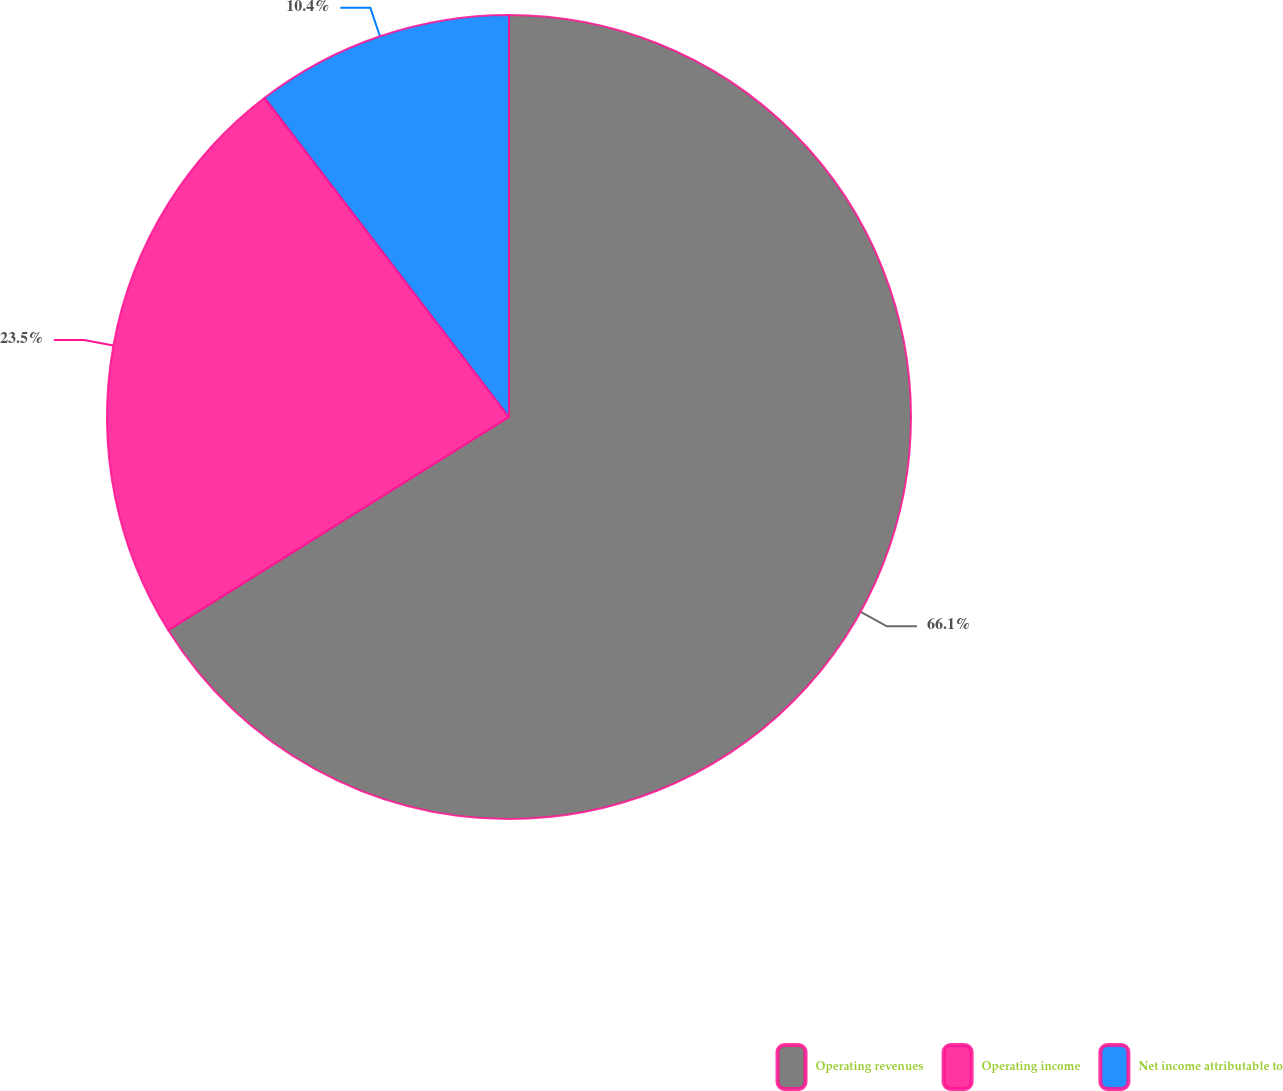<chart> <loc_0><loc_0><loc_500><loc_500><pie_chart><fcel>Operating revenues<fcel>Operating income<fcel>Net income attributable to<nl><fcel>66.1%<fcel>23.5%<fcel>10.4%<nl></chart> 